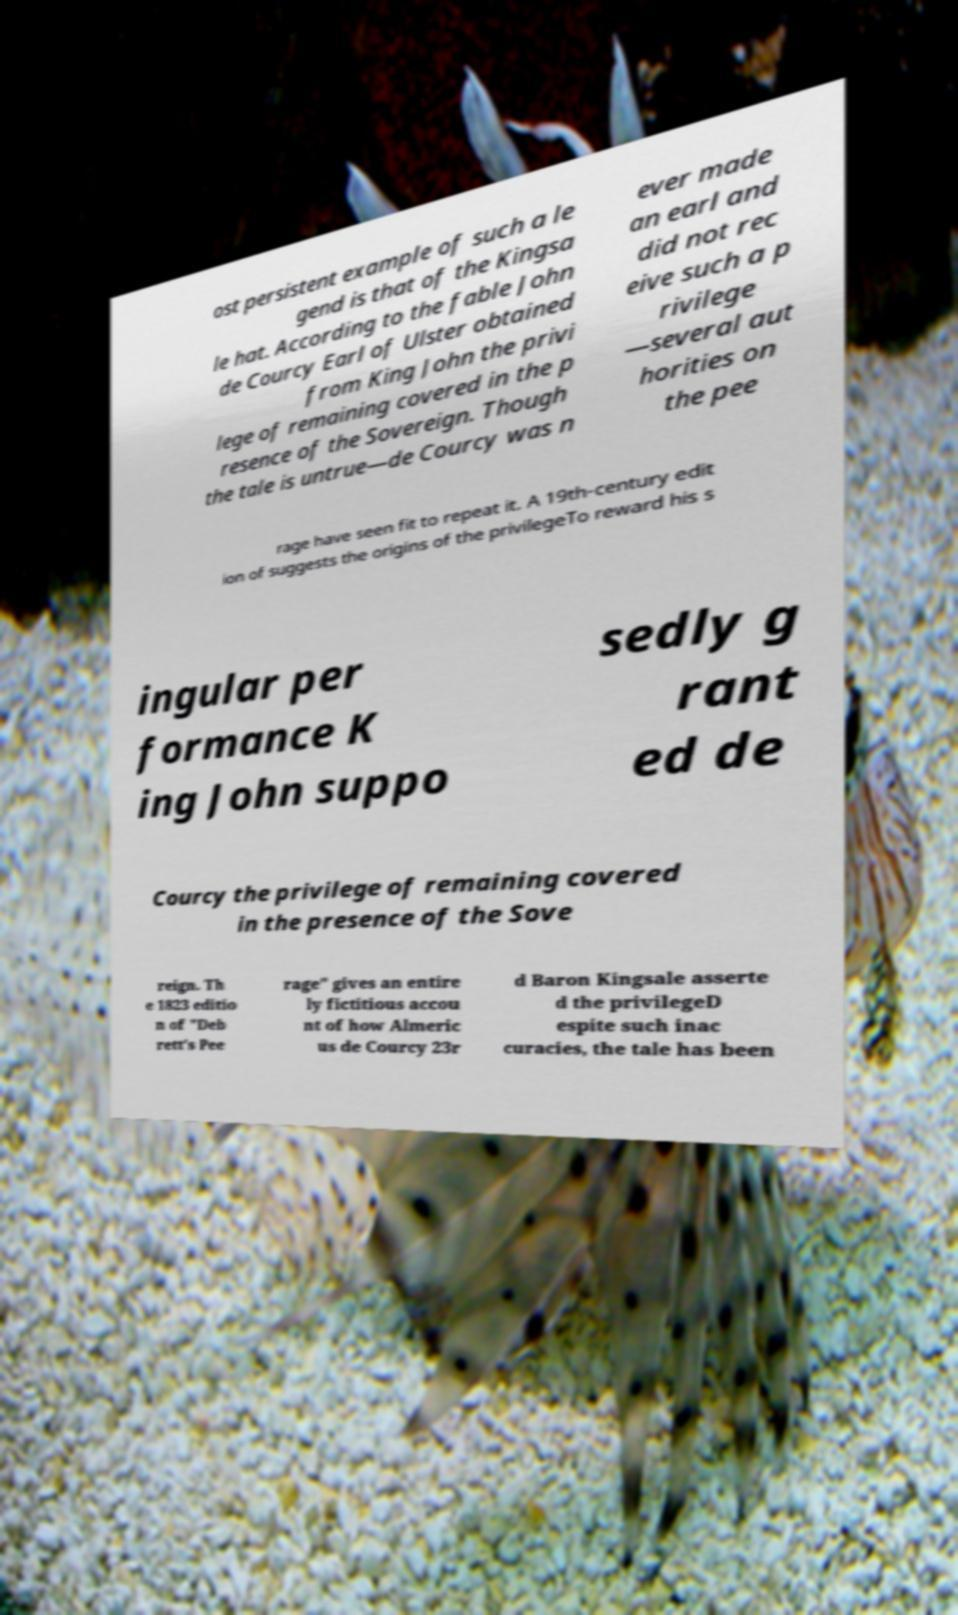What messages or text are displayed in this image? I need them in a readable, typed format. ost persistent example of such a le gend is that of the Kingsa le hat. According to the fable John de Courcy Earl of Ulster obtained from King John the privi lege of remaining covered in the p resence of the Sovereign. Though the tale is untrue—de Courcy was n ever made an earl and did not rec eive such a p rivilege —several aut horities on the pee rage have seen fit to repeat it. A 19th-century edit ion of suggests the origins of the privilegeTo reward his s ingular per formance K ing John suppo sedly g rant ed de Courcy the privilege of remaining covered in the presence of the Sove reign. Th e 1823 editio n of "Deb rett's Pee rage" gives an entire ly fictitious accou nt of how Almeric us de Courcy 23r d Baron Kingsale asserte d the privilegeD espite such inac curacies, the tale has been 